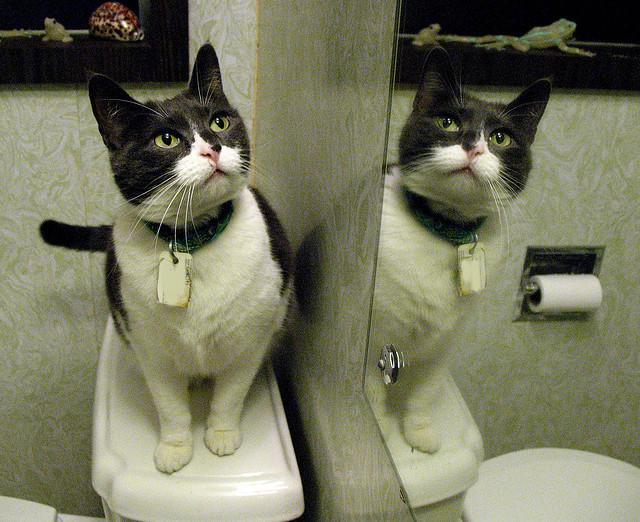How many toilets can you see?
Give a very brief answer. 2. How many cats are in the picture?
Give a very brief answer. 2. 